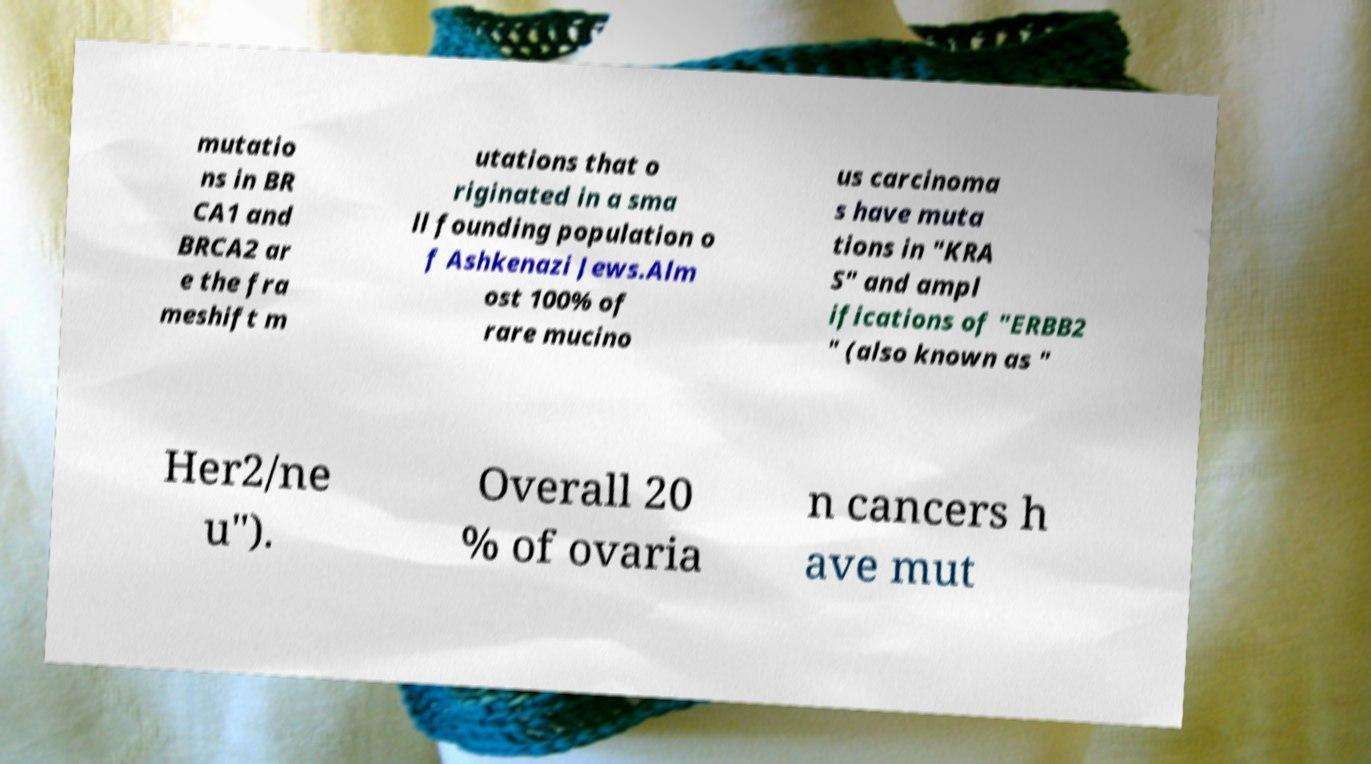What messages or text are displayed in this image? I need them in a readable, typed format. mutatio ns in BR CA1 and BRCA2 ar e the fra meshift m utations that o riginated in a sma ll founding population o f Ashkenazi Jews.Alm ost 100% of rare mucino us carcinoma s have muta tions in "KRA S" and ampl ifications of "ERBB2 " (also known as " Her2/ne u"). Overall 20 % of ovaria n cancers h ave mut 